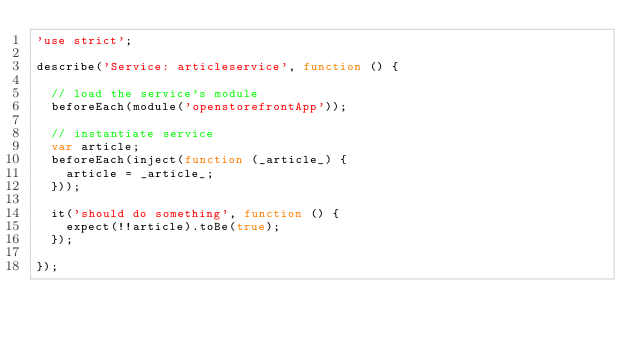<code> <loc_0><loc_0><loc_500><loc_500><_JavaScript_>'use strict';

describe('Service: articleservice', function () {

  // load the service's module
  beforeEach(module('openstorefrontApp'));

  // instantiate service
  var article;
  beforeEach(inject(function (_article_) {
    article = _article_;
  }));

  it('should do something', function () {
    expect(!!article).toBe(true);
  });

});
</code> 